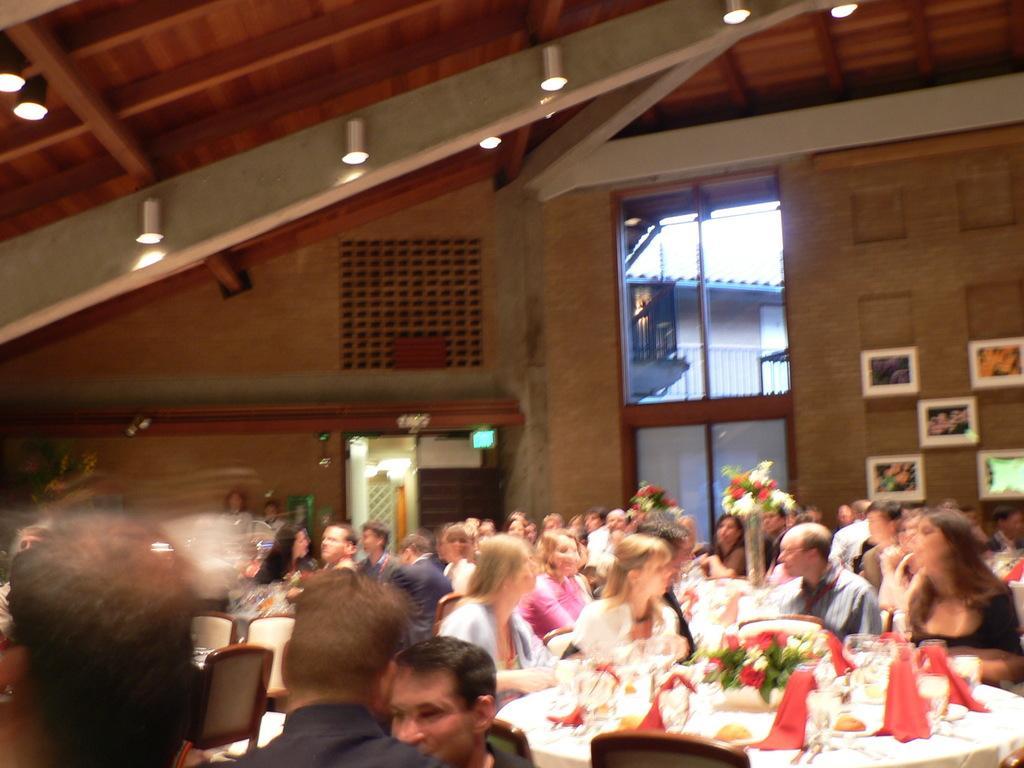In one or two sentences, can you explain what this image depicts? This picture shows a group of people seated on the chairs and we see few bottles,flowers ,forks and spoons on the table and we see few lights on the roof can we see a building from the window and few photo frames on the wall 